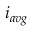<formula> <loc_0><loc_0><loc_500><loc_500>i _ { a v g }</formula> 